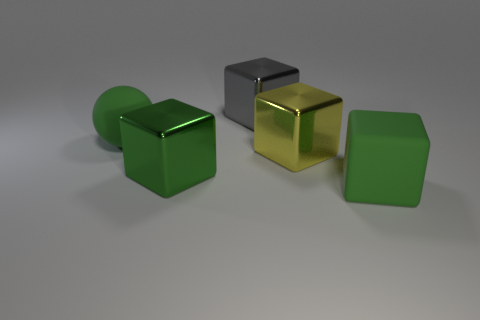Are there the same number of large things in front of the gray block and gray metallic objects?
Give a very brief answer. No. What number of other things are there of the same color as the matte block?
Provide a short and direct response. 2. What color is the thing that is both in front of the gray thing and behind the yellow shiny object?
Your response must be concise. Green. What size is the green matte thing that is behind the big matte object that is in front of the large metallic thing on the right side of the gray thing?
Give a very brief answer. Large. What number of objects are either cubes that are behind the big yellow block or green objects behind the big yellow thing?
Make the answer very short. 2. What shape is the gray metal object?
Your response must be concise. Cube. How many other objects are the same material as the gray cube?
Give a very brief answer. 2. There is a yellow metal object that is the same shape as the gray metal thing; what size is it?
Provide a short and direct response. Large. The large block left of the cube that is behind the large shiny cube that is on the right side of the gray metallic block is made of what material?
Keep it short and to the point. Metal. Are there any cyan matte cubes?
Offer a very short reply. No. 